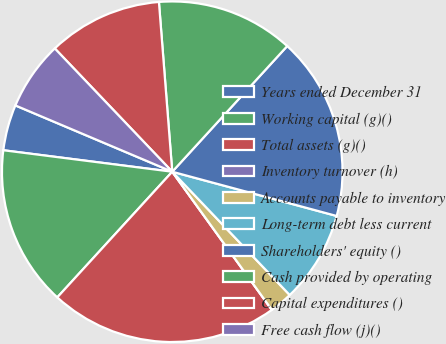Convert chart. <chart><loc_0><loc_0><loc_500><loc_500><pie_chart><fcel>Years ended December 31<fcel>Working capital (g)()<fcel>Total assets (g)()<fcel>Inventory turnover (h)<fcel>Accounts payable to inventory<fcel>Long-term debt less current<fcel>Shareholders' equity ()<fcel>Cash provided by operating<fcel>Capital expenditures ()<fcel>Free cash flow (j)()<nl><fcel>4.35%<fcel>15.22%<fcel>21.74%<fcel>0.0%<fcel>2.17%<fcel>8.7%<fcel>17.39%<fcel>13.04%<fcel>10.87%<fcel>6.52%<nl></chart> 